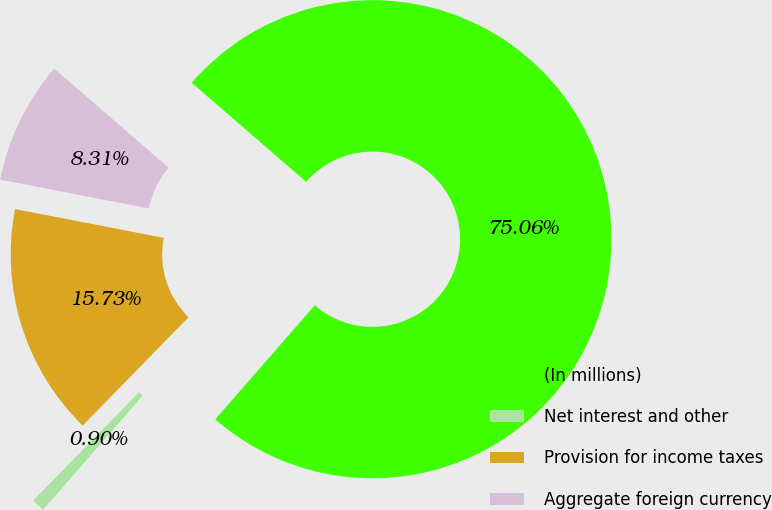Convert chart to OTSL. <chart><loc_0><loc_0><loc_500><loc_500><pie_chart><fcel>(In millions)<fcel>Net interest and other<fcel>Provision for income taxes<fcel>Aggregate foreign currency<nl><fcel>75.06%<fcel>0.9%<fcel>15.73%<fcel>8.31%<nl></chart> 